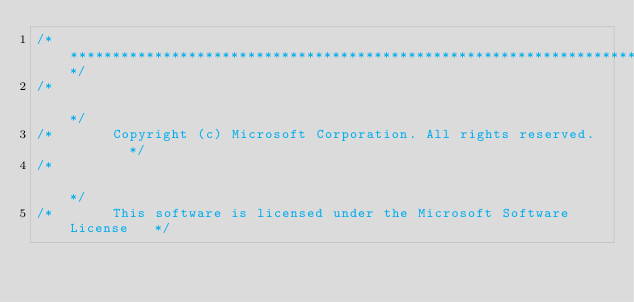<code> <loc_0><loc_0><loc_500><loc_500><_C_>/**************************************************************************/
/*                                                                        */
/*       Copyright (c) Microsoft Corporation. All rights reserved.        */
/*                                                                        */
/*       This software is licensed under the Microsoft Software License   */</code> 